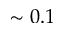Convert formula to latex. <formula><loc_0><loc_0><loc_500><loc_500>\sim 0 . 1</formula> 